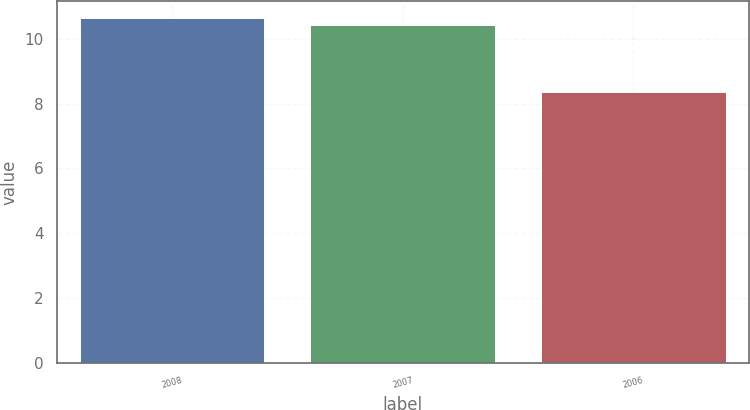<chart> <loc_0><loc_0><loc_500><loc_500><bar_chart><fcel>2008<fcel>2007<fcel>2006<nl><fcel>10.63<fcel>10.41<fcel>8.36<nl></chart> 